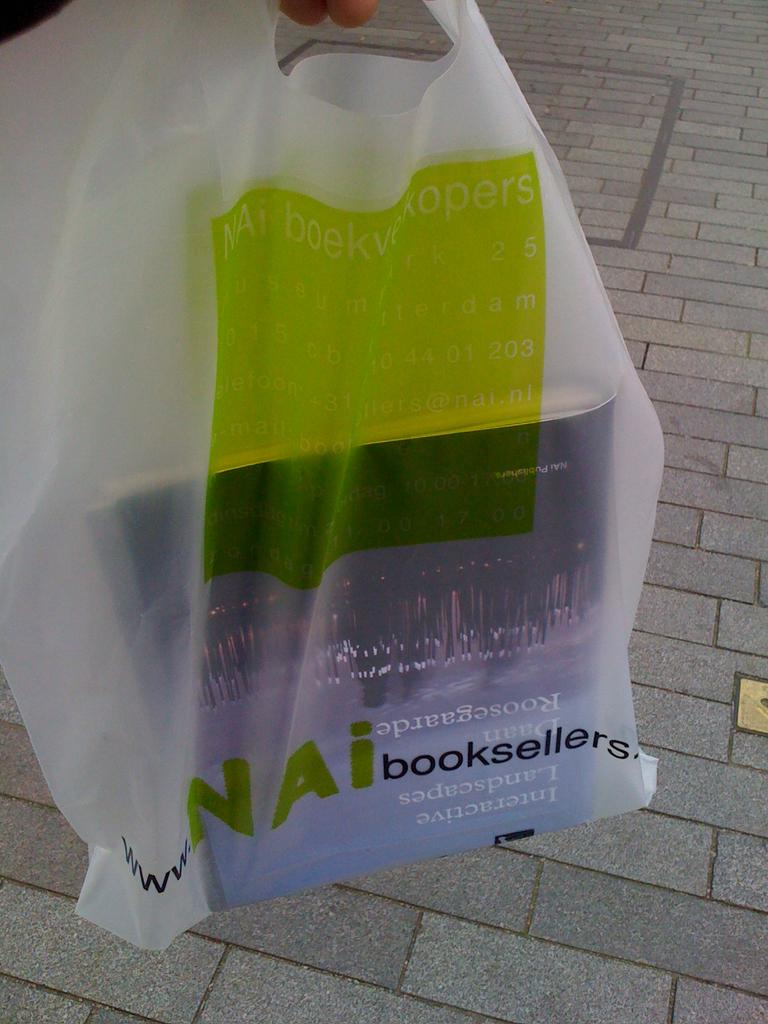What is the main object in the image? There is a book in a plastic cover in the image. Can you describe the condition of the book? The book is in a plastic cover, which suggests it is being protected or preserved. How many dimes can be seen stacked on top of the bread in the image? There is no bread or dimes present in the image; it only features a book in a plastic cover. 